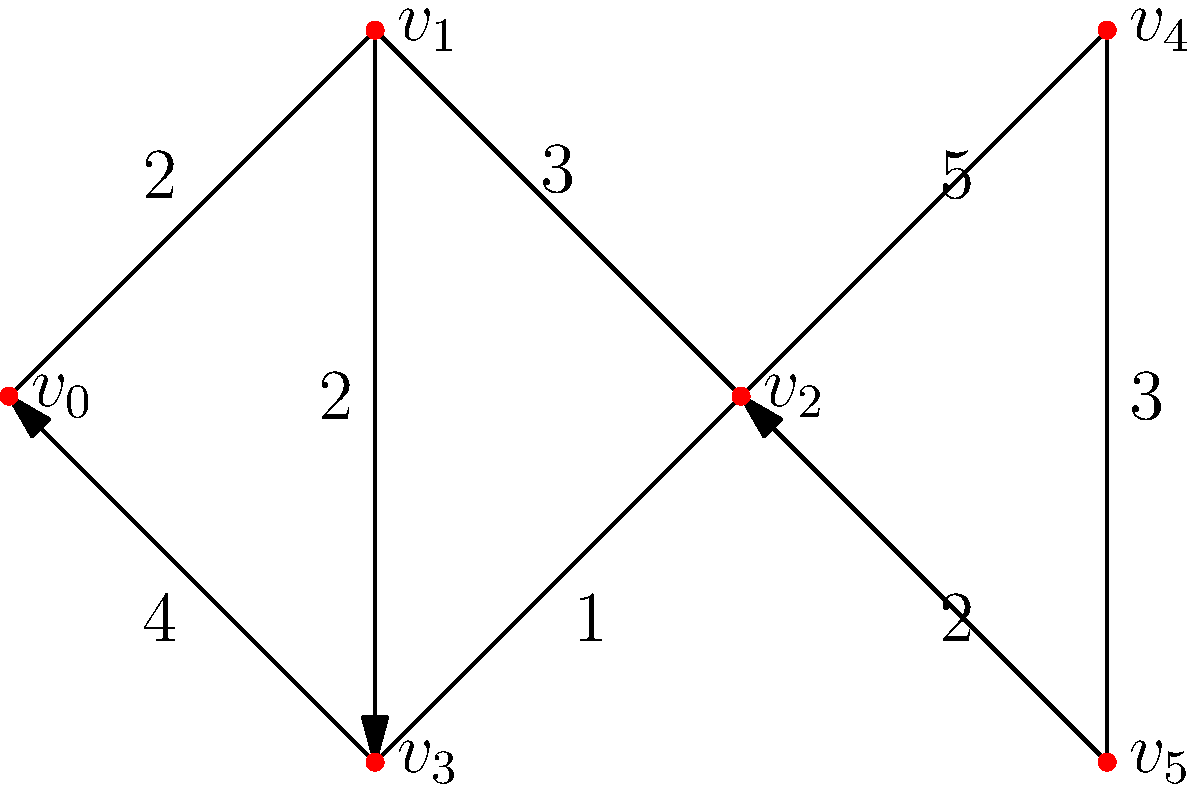Given the network topology of a campus security system where vertices represent cameras and access points, and edges represent connections with their associated latency (in milliseconds), what is the minimum latency path from $v_0$ to $v_5$? To find the minimum latency path from $v_0$ to $v_5$, we need to consider all possible paths and calculate their total latencies:

1. Path 1: $v_0 \rightarrow v_1 \rightarrow v_2 \rightarrow v_5$
   Latency = 2 + 3 + 2 = 7 ms

2. Path 2: $v_0 \rightarrow v_3 \rightarrow v_2 \rightarrow v_5$
   Latency = 4 + 1 + 2 = 7 ms

3. Path 3: $v_0 \rightarrow v_1 \rightarrow v_2 \rightarrow v_4 \rightarrow v_5$
   Latency = 2 + 3 + 5 + 3 = 13 ms

4. Path 4: $v_0 \rightarrow v_3 \rightarrow v_2 \rightarrow v_4 \rightarrow v_5$
   Latency = 4 + 1 + 5 + 3 = 13 ms

5. Path 5: $v_0 \rightarrow v_1 \rightarrow v_3 \rightarrow v_2 \rightarrow v_5$
   Latency = 2 + 2 + 1 + 2 = 7 ms

6. Path 6: $v_0 \rightarrow v_3 \rightarrow v_1 \rightarrow v_2 \rightarrow v_5$
   Latency = 4 + 2 + 3 + 2 = 11 ms

The minimum latency paths are Path 1, Path 2, and Path 5, all with a total latency of 7 ms. Among these, the shortest path in terms of the number of hops is Path 1: $v_0 \rightarrow v_1 \rightarrow v_2 \rightarrow v_5$.
Answer: $v_0 \rightarrow v_1 \rightarrow v_2 \rightarrow v_5$ (7 ms) 